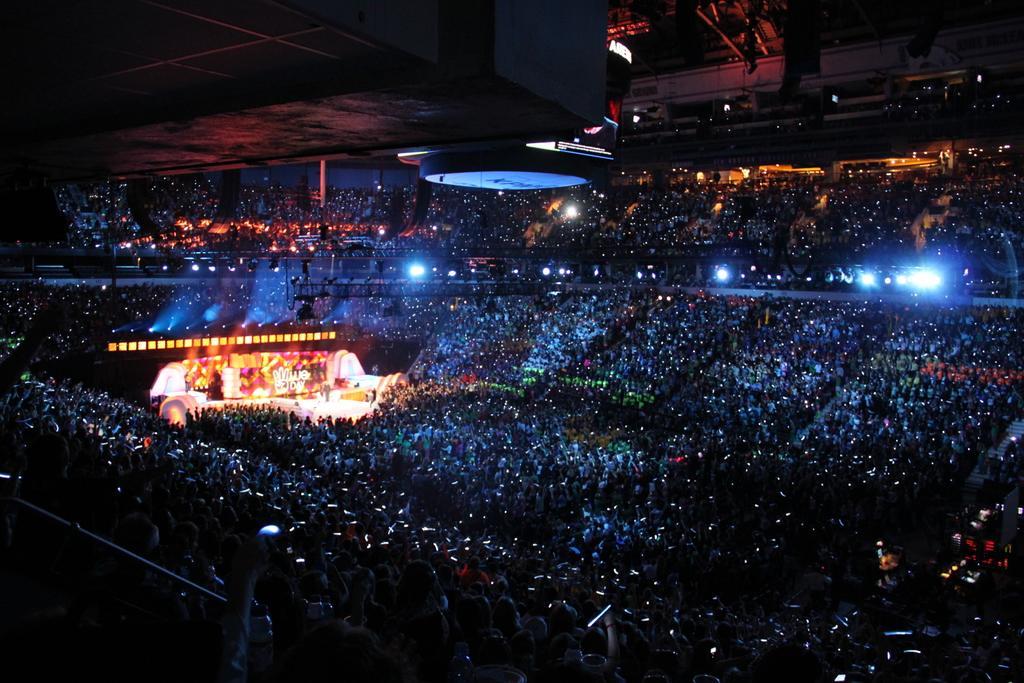Can you describe this image briefly? In the image it looks like some concert, there is a stage on the left side and around the stage there is a huge crowd. 